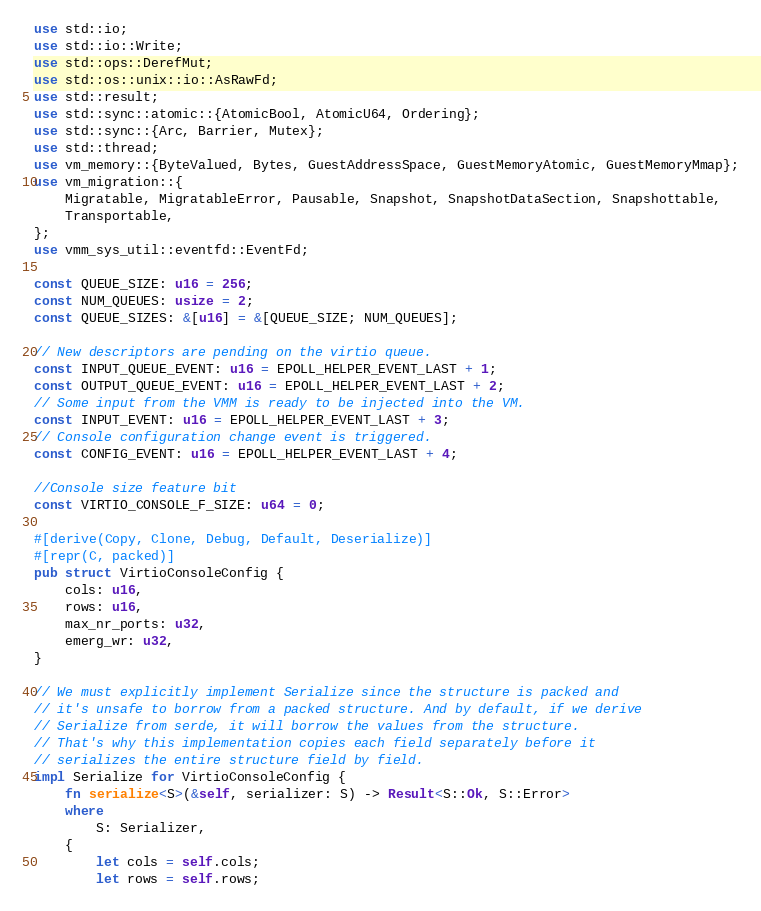Convert code to text. <code><loc_0><loc_0><loc_500><loc_500><_Rust_>use std::io;
use std::io::Write;
use std::ops::DerefMut;
use std::os::unix::io::AsRawFd;
use std::result;
use std::sync::atomic::{AtomicBool, AtomicU64, Ordering};
use std::sync::{Arc, Barrier, Mutex};
use std::thread;
use vm_memory::{ByteValued, Bytes, GuestAddressSpace, GuestMemoryAtomic, GuestMemoryMmap};
use vm_migration::{
    Migratable, MigratableError, Pausable, Snapshot, SnapshotDataSection, Snapshottable,
    Transportable,
};
use vmm_sys_util::eventfd::EventFd;

const QUEUE_SIZE: u16 = 256;
const NUM_QUEUES: usize = 2;
const QUEUE_SIZES: &[u16] = &[QUEUE_SIZE; NUM_QUEUES];

// New descriptors are pending on the virtio queue.
const INPUT_QUEUE_EVENT: u16 = EPOLL_HELPER_EVENT_LAST + 1;
const OUTPUT_QUEUE_EVENT: u16 = EPOLL_HELPER_EVENT_LAST + 2;
// Some input from the VMM is ready to be injected into the VM.
const INPUT_EVENT: u16 = EPOLL_HELPER_EVENT_LAST + 3;
// Console configuration change event is triggered.
const CONFIG_EVENT: u16 = EPOLL_HELPER_EVENT_LAST + 4;

//Console size feature bit
const VIRTIO_CONSOLE_F_SIZE: u64 = 0;

#[derive(Copy, Clone, Debug, Default, Deserialize)]
#[repr(C, packed)]
pub struct VirtioConsoleConfig {
    cols: u16,
    rows: u16,
    max_nr_ports: u32,
    emerg_wr: u32,
}

// We must explicitly implement Serialize since the structure is packed and
// it's unsafe to borrow from a packed structure. And by default, if we derive
// Serialize from serde, it will borrow the values from the structure.
// That's why this implementation copies each field separately before it
// serializes the entire structure field by field.
impl Serialize for VirtioConsoleConfig {
    fn serialize<S>(&self, serializer: S) -> Result<S::Ok, S::Error>
    where
        S: Serializer,
    {
        let cols = self.cols;
        let rows = self.rows;</code> 